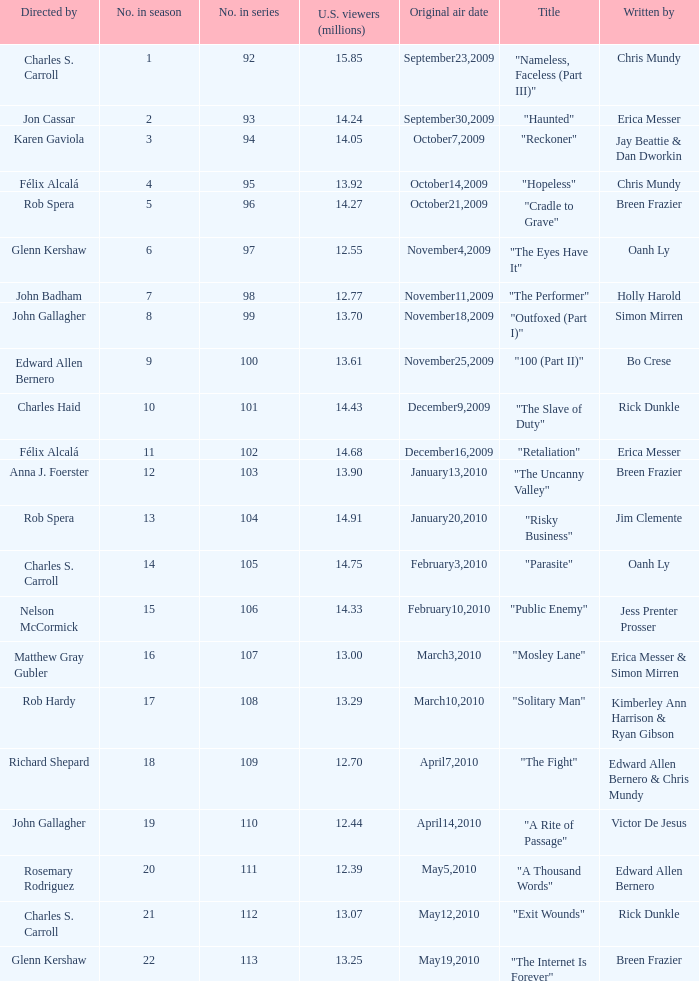What number(s) in the series was written by bo crese? 100.0. 